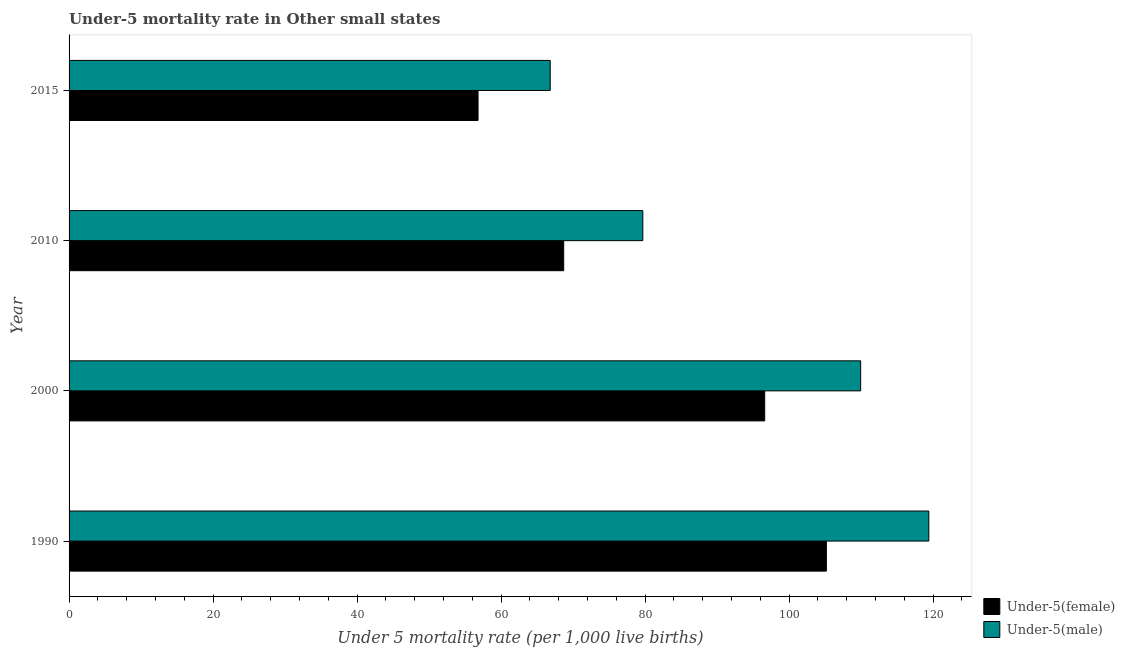How many different coloured bars are there?
Offer a very short reply. 2. How many groups of bars are there?
Provide a succinct answer. 4. How many bars are there on the 4th tick from the top?
Your answer should be very brief. 2. What is the label of the 3rd group of bars from the top?
Ensure brevity in your answer.  2000. What is the under-5 female mortality rate in 1990?
Make the answer very short. 105.19. Across all years, what is the maximum under-5 female mortality rate?
Keep it short and to the point. 105.19. Across all years, what is the minimum under-5 female mortality rate?
Your response must be concise. 56.81. In which year was the under-5 female mortality rate minimum?
Make the answer very short. 2015. What is the total under-5 female mortality rate in the graph?
Give a very brief answer. 327.33. What is the difference between the under-5 female mortality rate in 2000 and that in 2010?
Provide a short and direct response. 27.92. What is the difference between the under-5 female mortality rate in 2010 and the under-5 male mortality rate in 2000?
Give a very brief answer. -41.25. What is the average under-5 female mortality rate per year?
Give a very brief answer. 81.83. In the year 1990, what is the difference between the under-5 male mortality rate and under-5 female mortality rate?
Provide a short and direct response. 14.23. What is the ratio of the under-5 male mortality rate in 2000 to that in 2010?
Provide a short and direct response. 1.38. Is the under-5 female mortality rate in 1990 less than that in 2015?
Ensure brevity in your answer.  No. Is the difference between the under-5 female mortality rate in 1990 and 2000 greater than the difference between the under-5 male mortality rate in 1990 and 2000?
Offer a terse response. No. What is the difference between the highest and the second highest under-5 female mortality rate?
Make the answer very short. 8.57. What is the difference between the highest and the lowest under-5 male mortality rate?
Your answer should be compact. 52.59. Is the sum of the under-5 female mortality rate in 1990 and 2015 greater than the maximum under-5 male mortality rate across all years?
Provide a succinct answer. Yes. What does the 2nd bar from the top in 2015 represents?
Offer a very short reply. Under-5(female). What does the 1st bar from the bottom in 2000 represents?
Provide a succinct answer. Under-5(female). How many bars are there?
Provide a succinct answer. 8. Are all the bars in the graph horizontal?
Your response must be concise. Yes. How many years are there in the graph?
Offer a terse response. 4. What is the difference between two consecutive major ticks on the X-axis?
Give a very brief answer. 20. Does the graph contain any zero values?
Your answer should be compact. No. Does the graph contain grids?
Give a very brief answer. No. How are the legend labels stacked?
Give a very brief answer. Vertical. What is the title of the graph?
Keep it short and to the point. Under-5 mortality rate in Other small states. What is the label or title of the X-axis?
Ensure brevity in your answer.  Under 5 mortality rate (per 1,0 live births). What is the Under 5 mortality rate (per 1,000 live births) of Under-5(female) in 1990?
Your response must be concise. 105.19. What is the Under 5 mortality rate (per 1,000 live births) of Under-5(male) in 1990?
Ensure brevity in your answer.  119.42. What is the Under 5 mortality rate (per 1,000 live births) in Under-5(female) in 2000?
Your response must be concise. 96.62. What is the Under 5 mortality rate (per 1,000 live births) of Under-5(male) in 2000?
Your answer should be very brief. 109.95. What is the Under 5 mortality rate (per 1,000 live births) in Under-5(female) in 2010?
Provide a short and direct response. 68.7. What is the Under 5 mortality rate (per 1,000 live births) in Under-5(male) in 2010?
Provide a succinct answer. 79.69. What is the Under 5 mortality rate (per 1,000 live births) in Under-5(female) in 2015?
Provide a succinct answer. 56.81. What is the Under 5 mortality rate (per 1,000 live births) in Under-5(male) in 2015?
Ensure brevity in your answer.  66.83. Across all years, what is the maximum Under 5 mortality rate (per 1,000 live births) in Under-5(female)?
Keep it short and to the point. 105.19. Across all years, what is the maximum Under 5 mortality rate (per 1,000 live births) of Under-5(male)?
Offer a terse response. 119.42. Across all years, what is the minimum Under 5 mortality rate (per 1,000 live births) in Under-5(female)?
Keep it short and to the point. 56.81. Across all years, what is the minimum Under 5 mortality rate (per 1,000 live births) of Under-5(male)?
Ensure brevity in your answer.  66.83. What is the total Under 5 mortality rate (per 1,000 live births) of Under-5(female) in the graph?
Provide a succinct answer. 327.33. What is the total Under 5 mortality rate (per 1,000 live births) in Under-5(male) in the graph?
Provide a succinct answer. 375.9. What is the difference between the Under 5 mortality rate (per 1,000 live births) of Under-5(female) in 1990 and that in 2000?
Your answer should be compact. 8.57. What is the difference between the Under 5 mortality rate (per 1,000 live births) in Under-5(male) in 1990 and that in 2000?
Give a very brief answer. 9.47. What is the difference between the Under 5 mortality rate (per 1,000 live births) in Under-5(female) in 1990 and that in 2010?
Your answer should be compact. 36.49. What is the difference between the Under 5 mortality rate (per 1,000 live births) of Under-5(male) in 1990 and that in 2010?
Your answer should be compact. 39.73. What is the difference between the Under 5 mortality rate (per 1,000 live births) of Under-5(female) in 1990 and that in 2015?
Provide a succinct answer. 48.38. What is the difference between the Under 5 mortality rate (per 1,000 live births) in Under-5(male) in 1990 and that in 2015?
Provide a succinct answer. 52.59. What is the difference between the Under 5 mortality rate (per 1,000 live births) of Under-5(female) in 2000 and that in 2010?
Your response must be concise. 27.92. What is the difference between the Under 5 mortality rate (per 1,000 live births) of Under-5(male) in 2000 and that in 2010?
Make the answer very short. 30.26. What is the difference between the Under 5 mortality rate (per 1,000 live births) in Under-5(female) in 2000 and that in 2015?
Offer a very short reply. 39.82. What is the difference between the Under 5 mortality rate (per 1,000 live births) in Under-5(male) in 2000 and that in 2015?
Your response must be concise. 43.12. What is the difference between the Under 5 mortality rate (per 1,000 live births) in Under-5(female) in 2010 and that in 2015?
Make the answer very short. 11.9. What is the difference between the Under 5 mortality rate (per 1,000 live births) in Under-5(male) in 2010 and that in 2015?
Offer a terse response. 12.86. What is the difference between the Under 5 mortality rate (per 1,000 live births) in Under-5(female) in 1990 and the Under 5 mortality rate (per 1,000 live births) in Under-5(male) in 2000?
Provide a short and direct response. -4.76. What is the difference between the Under 5 mortality rate (per 1,000 live births) in Under-5(female) in 1990 and the Under 5 mortality rate (per 1,000 live births) in Under-5(male) in 2010?
Ensure brevity in your answer.  25.5. What is the difference between the Under 5 mortality rate (per 1,000 live births) of Under-5(female) in 1990 and the Under 5 mortality rate (per 1,000 live births) of Under-5(male) in 2015?
Ensure brevity in your answer.  38.36. What is the difference between the Under 5 mortality rate (per 1,000 live births) of Under-5(female) in 2000 and the Under 5 mortality rate (per 1,000 live births) of Under-5(male) in 2010?
Your answer should be compact. 16.93. What is the difference between the Under 5 mortality rate (per 1,000 live births) of Under-5(female) in 2000 and the Under 5 mortality rate (per 1,000 live births) of Under-5(male) in 2015?
Make the answer very short. 29.79. What is the difference between the Under 5 mortality rate (per 1,000 live births) in Under-5(female) in 2010 and the Under 5 mortality rate (per 1,000 live births) in Under-5(male) in 2015?
Your answer should be compact. 1.87. What is the average Under 5 mortality rate (per 1,000 live births) in Under-5(female) per year?
Offer a terse response. 81.83. What is the average Under 5 mortality rate (per 1,000 live births) of Under-5(male) per year?
Offer a very short reply. 93.97. In the year 1990, what is the difference between the Under 5 mortality rate (per 1,000 live births) of Under-5(female) and Under 5 mortality rate (per 1,000 live births) of Under-5(male)?
Offer a very short reply. -14.23. In the year 2000, what is the difference between the Under 5 mortality rate (per 1,000 live births) of Under-5(female) and Under 5 mortality rate (per 1,000 live births) of Under-5(male)?
Offer a very short reply. -13.33. In the year 2010, what is the difference between the Under 5 mortality rate (per 1,000 live births) of Under-5(female) and Under 5 mortality rate (per 1,000 live births) of Under-5(male)?
Your answer should be compact. -10.99. In the year 2015, what is the difference between the Under 5 mortality rate (per 1,000 live births) in Under-5(female) and Under 5 mortality rate (per 1,000 live births) in Under-5(male)?
Your answer should be compact. -10.03. What is the ratio of the Under 5 mortality rate (per 1,000 live births) of Under-5(female) in 1990 to that in 2000?
Offer a terse response. 1.09. What is the ratio of the Under 5 mortality rate (per 1,000 live births) of Under-5(male) in 1990 to that in 2000?
Offer a terse response. 1.09. What is the ratio of the Under 5 mortality rate (per 1,000 live births) in Under-5(female) in 1990 to that in 2010?
Keep it short and to the point. 1.53. What is the ratio of the Under 5 mortality rate (per 1,000 live births) in Under-5(male) in 1990 to that in 2010?
Make the answer very short. 1.5. What is the ratio of the Under 5 mortality rate (per 1,000 live births) in Under-5(female) in 1990 to that in 2015?
Make the answer very short. 1.85. What is the ratio of the Under 5 mortality rate (per 1,000 live births) of Under-5(male) in 1990 to that in 2015?
Give a very brief answer. 1.79. What is the ratio of the Under 5 mortality rate (per 1,000 live births) of Under-5(female) in 2000 to that in 2010?
Make the answer very short. 1.41. What is the ratio of the Under 5 mortality rate (per 1,000 live births) of Under-5(male) in 2000 to that in 2010?
Your answer should be very brief. 1.38. What is the ratio of the Under 5 mortality rate (per 1,000 live births) in Under-5(female) in 2000 to that in 2015?
Provide a succinct answer. 1.7. What is the ratio of the Under 5 mortality rate (per 1,000 live births) in Under-5(male) in 2000 to that in 2015?
Your response must be concise. 1.65. What is the ratio of the Under 5 mortality rate (per 1,000 live births) in Under-5(female) in 2010 to that in 2015?
Provide a succinct answer. 1.21. What is the ratio of the Under 5 mortality rate (per 1,000 live births) in Under-5(male) in 2010 to that in 2015?
Your response must be concise. 1.19. What is the difference between the highest and the second highest Under 5 mortality rate (per 1,000 live births) in Under-5(female)?
Provide a short and direct response. 8.57. What is the difference between the highest and the second highest Under 5 mortality rate (per 1,000 live births) of Under-5(male)?
Provide a succinct answer. 9.47. What is the difference between the highest and the lowest Under 5 mortality rate (per 1,000 live births) of Under-5(female)?
Your response must be concise. 48.38. What is the difference between the highest and the lowest Under 5 mortality rate (per 1,000 live births) in Under-5(male)?
Ensure brevity in your answer.  52.59. 